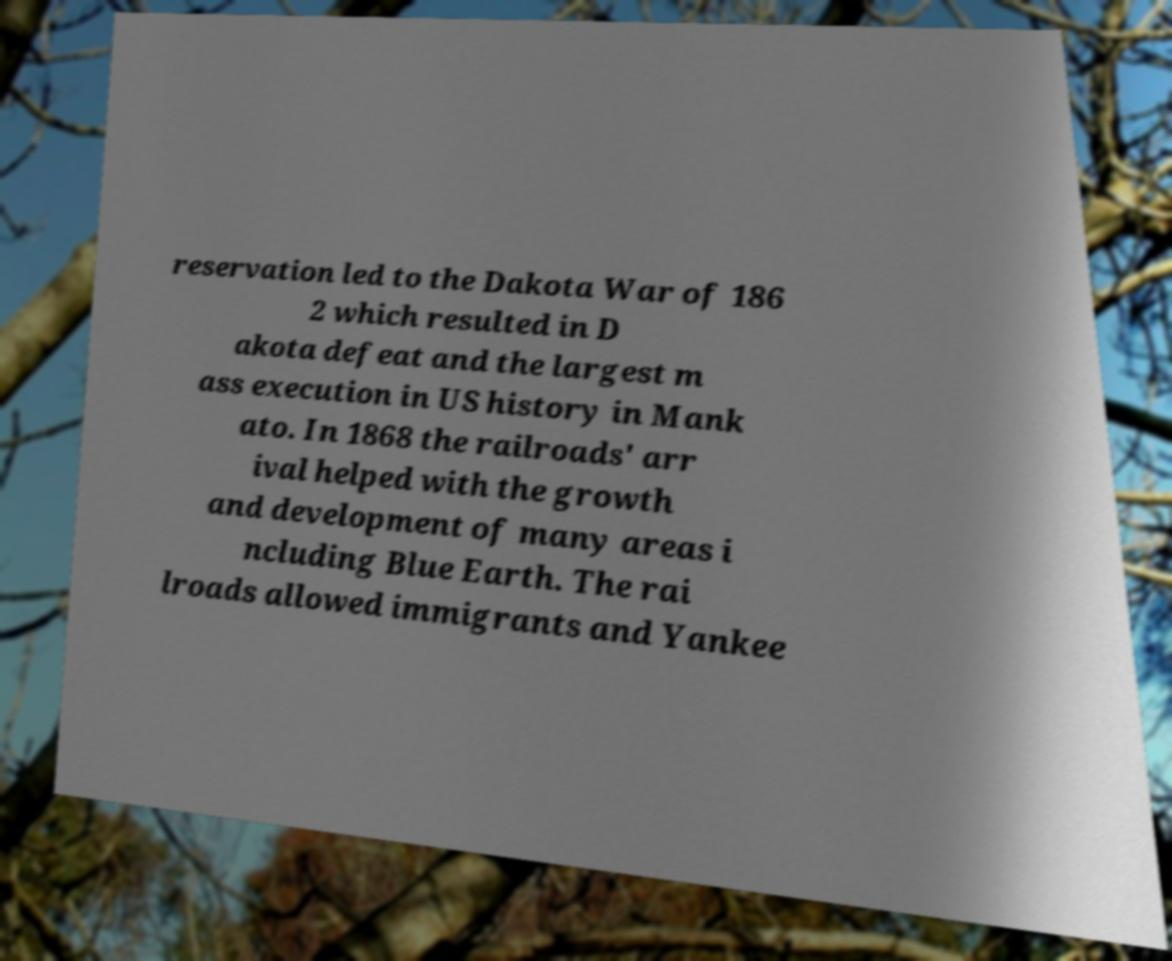For documentation purposes, I need the text within this image transcribed. Could you provide that? reservation led to the Dakota War of 186 2 which resulted in D akota defeat and the largest m ass execution in US history in Mank ato. In 1868 the railroads' arr ival helped with the growth and development of many areas i ncluding Blue Earth. The rai lroads allowed immigrants and Yankee 